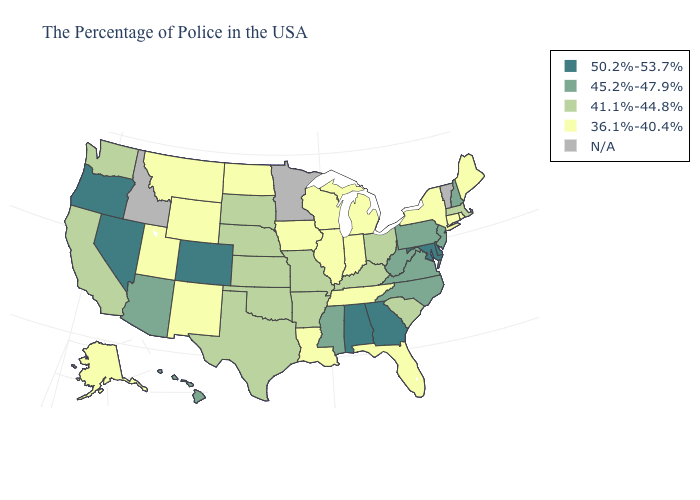What is the lowest value in the USA?
Be succinct. 36.1%-40.4%. How many symbols are there in the legend?
Give a very brief answer. 5. What is the value of Delaware?
Give a very brief answer. 50.2%-53.7%. Does Louisiana have the lowest value in the South?
Write a very short answer. Yes. What is the value of Alaska?
Answer briefly. 36.1%-40.4%. What is the lowest value in the Northeast?
Write a very short answer. 36.1%-40.4%. Which states have the lowest value in the South?
Short answer required. Florida, Tennessee, Louisiana. Among the states that border West Virginia , which have the lowest value?
Concise answer only. Ohio, Kentucky. Which states hav the highest value in the MidWest?
Short answer required. Ohio, Missouri, Kansas, Nebraska, South Dakota. Does the first symbol in the legend represent the smallest category?
Keep it brief. No. What is the value of Texas?
Give a very brief answer. 41.1%-44.8%. 